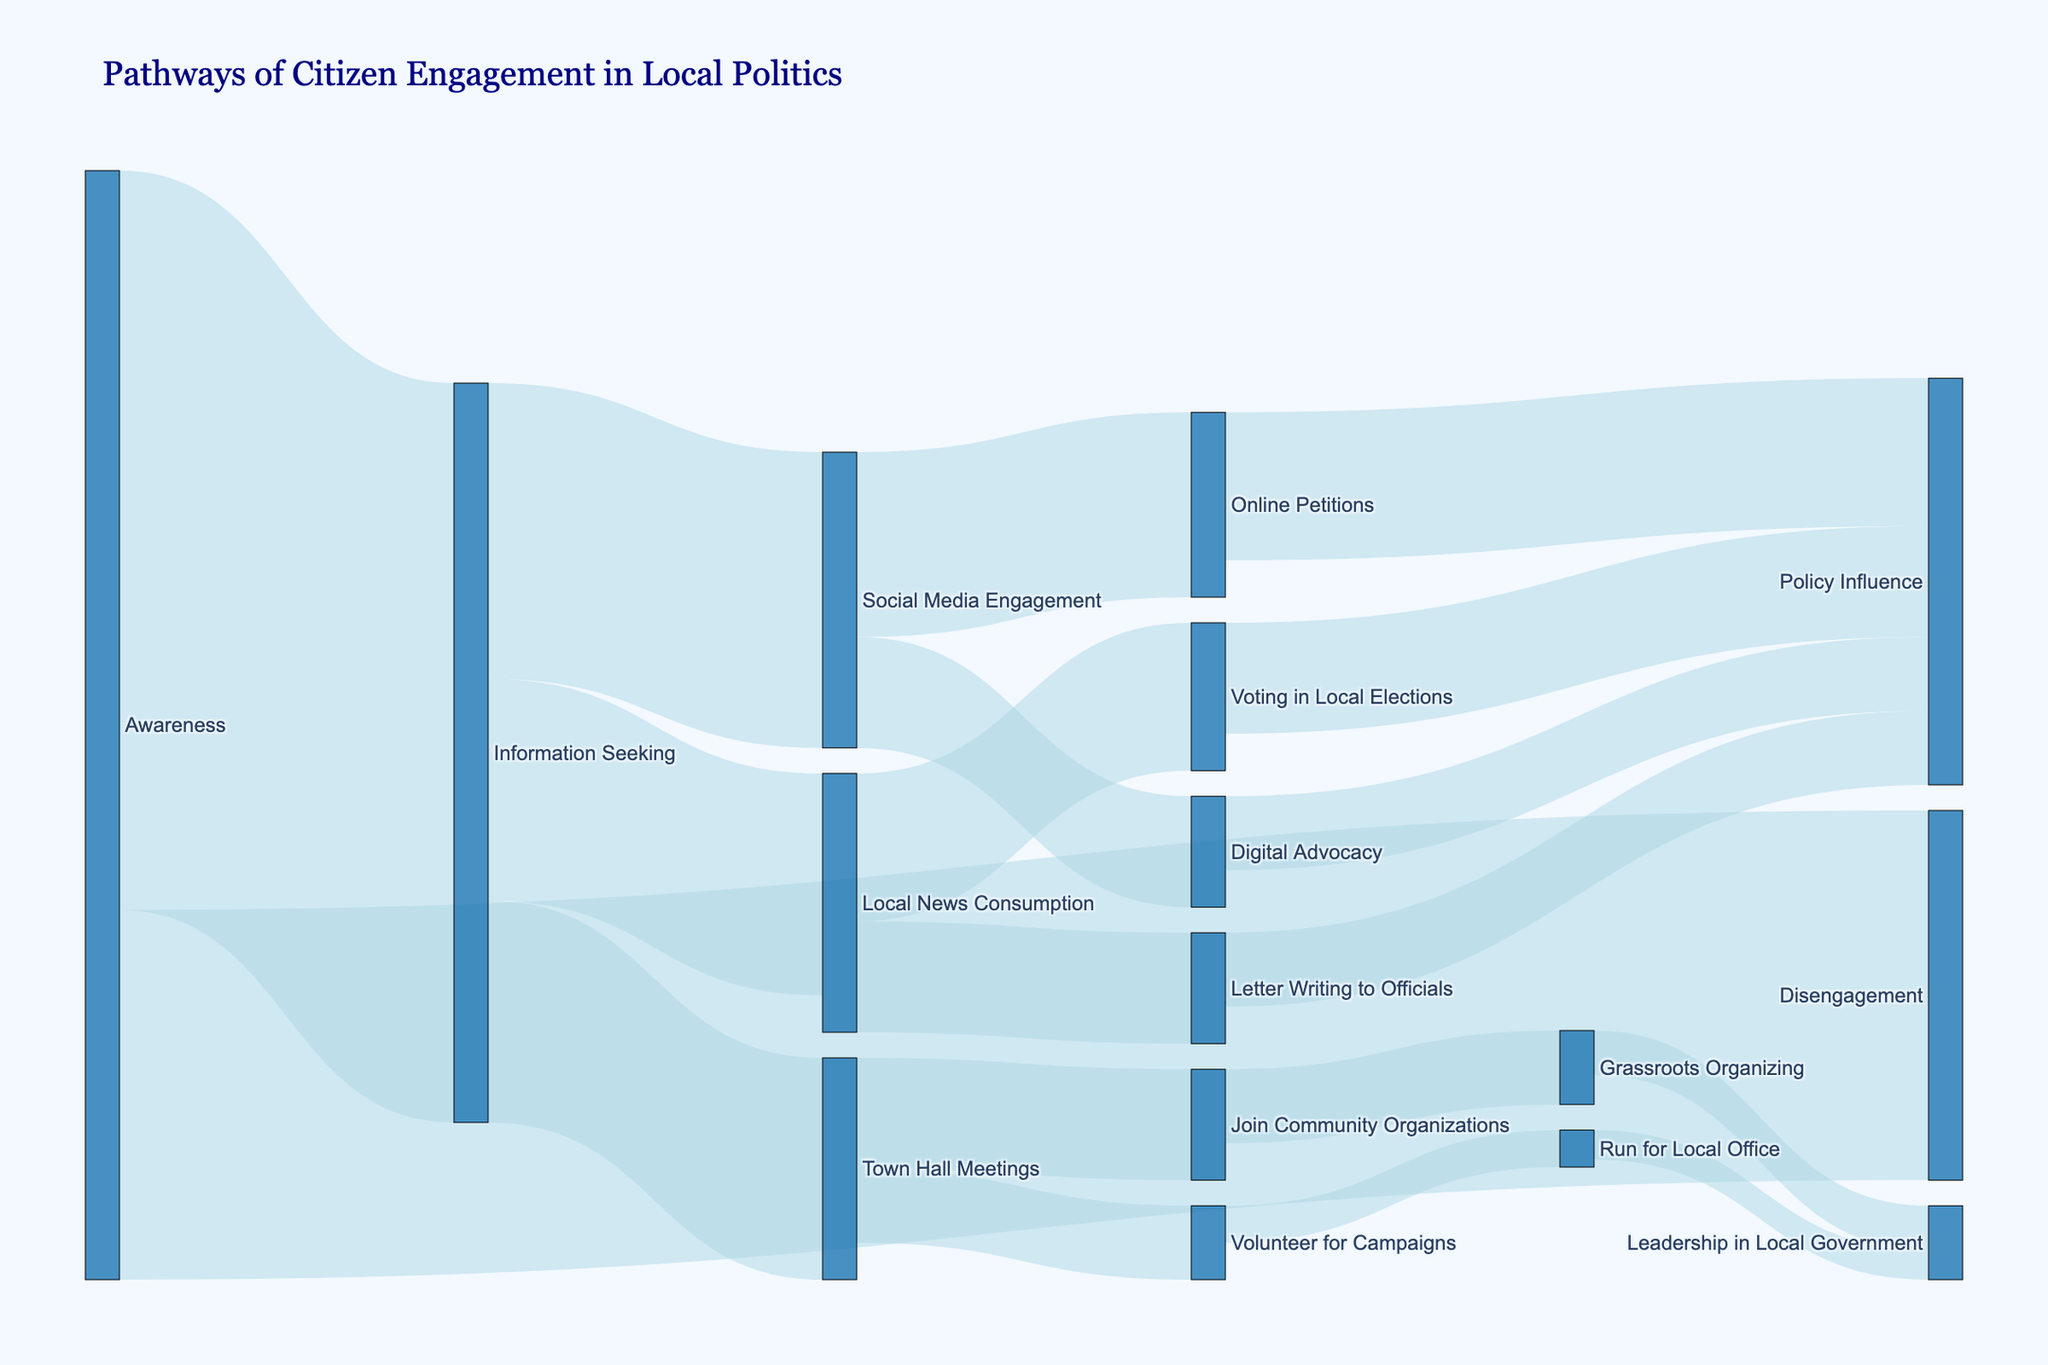Which pathway has the highest initial engagement from awareness? From the figure, "Awareness" splits into "Information Seeking," "Disengagement." The path with the highest value is "Information Seeking" with a value of 1000.
Answer: Information Seeking What is the total number of citizens that disengage at the awareness stage? From the figure, the value for the path from "Awareness" to "Disengagement" is given as 500.
Answer: 500 How many citizens participate in Town Hall Meetings? The figure shows a path from "Information Seeking" to "Town Hall Meetings" with a value of 300.
Answer: 300 What is the sum of citizens actively involved through Social Media Engagement and Local News Consumption? From the figure, "Social Media Engagement" has a value of 400 and "Local News Consumption" has a value of 300. Summing these values, 400 + 300 = 700.
Answer: 700 How many paths culminate in influencing policy? The figure shows paths ending in "Policy Influence" from "Online Petitions" (200), "Digital Advocacy" (100), "Letter Writing to Officials" (100), and "Voting in Local Elections" (150). That's a total of 4 paths.
Answer: 4 What is the least followed pathway from Information Seeking? The figure shows three pathways from "Information Seeking": "Town Hall Meetings" (300), "Social Media Engagement" (400), and "Local News Consumption" (300). The least value is for "Town Hall Meetings" with 300.
Answer: Town Hall Meetings What is the difference between the number of citizens who participate in Online Petitions and those who engage in Digital Advocacy? The figure shows that "Online Petitions" have a value of 250 and "Digital Advocacy" has a value of 150. The difference is 250 - 150 = 100.
Answer: 100 Which stage sees the highest engagement at the point of possible active participation related to policy influence? From the figure, "Voting in Local Elections" leads to "Policy Influence" with a value of 150, higher than any other source directing to "Policy Influence".
Answer: Voting in Local Elections 